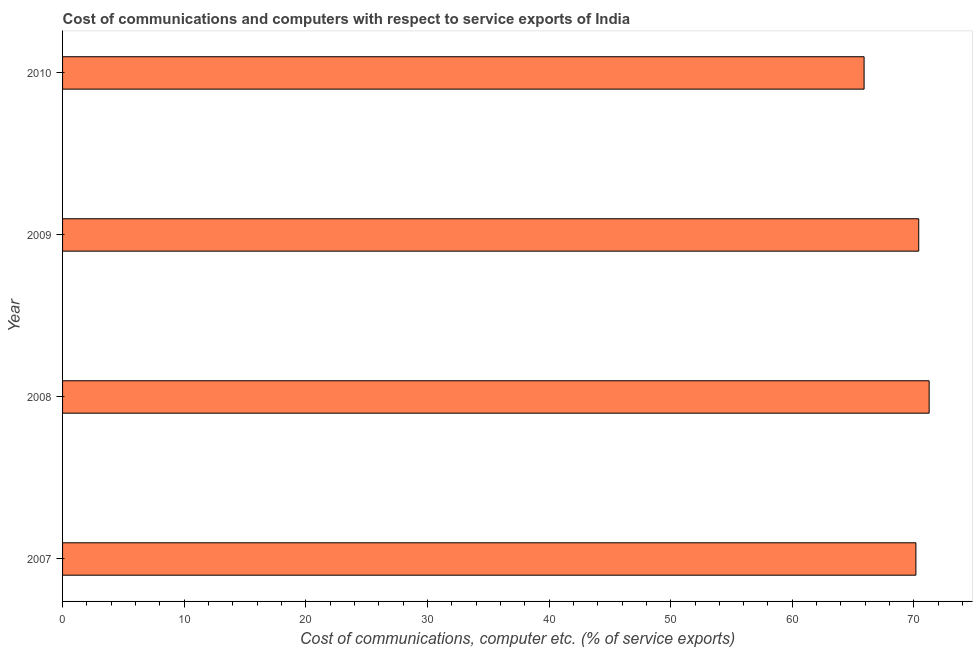Does the graph contain grids?
Your response must be concise. No. What is the title of the graph?
Keep it short and to the point. Cost of communications and computers with respect to service exports of India. What is the label or title of the X-axis?
Provide a short and direct response. Cost of communications, computer etc. (% of service exports). What is the label or title of the Y-axis?
Give a very brief answer. Year. What is the cost of communications and computer in 2008?
Offer a terse response. 71.25. Across all years, what is the maximum cost of communications and computer?
Make the answer very short. 71.25. Across all years, what is the minimum cost of communications and computer?
Make the answer very short. 65.9. What is the sum of the cost of communications and computer?
Your answer should be very brief. 277.71. What is the difference between the cost of communications and computer in 2007 and 2009?
Provide a short and direct response. -0.23. What is the average cost of communications and computer per year?
Make the answer very short. 69.43. What is the median cost of communications and computer?
Provide a succinct answer. 70.28. Do a majority of the years between 2009 and 2010 (inclusive) have cost of communications and computer greater than 26 %?
Your answer should be compact. Yes. What is the ratio of the cost of communications and computer in 2008 to that in 2009?
Give a very brief answer. 1.01. Is the difference between the cost of communications and computer in 2007 and 2009 greater than the difference between any two years?
Keep it short and to the point. No. What is the difference between the highest and the second highest cost of communications and computer?
Keep it short and to the point. 0.86. Is the sum of the cost of communications and computer in 2008 and 2010 greater than the maximum cost of communications and computer across all years?
Give a very brief answer. Yes. What is the difference between the highest and the lowest cost of communications and computer?
Make the answer very short. 5.35. Are all the bars in the graph horizontal?
Keep it short and to the point. Yes. How many years are there in the graph?
Keep it short and to the point. 4. What is the Cost of communications, computer etc. (% of service exports) of 2007?
Provide a short and direct response. 70.16. What is the Cost of communications, computer etc. (% of service exports) in 2008?
Keep it short and to the point. 71.25. What is the Cost of communications, computer etc. (% of service exports) of 2009?
Keep it short and to the point. 70.39. What is the Cost of communications, computer etc. (% of service exports) in 2010?
Your answer should be compact. 65.9. What is the difference between the Cost of communications, computer etc. (% of service exports) in 2007 and 2008?
Your response must be concise. -1.09. What is the difference between the Cost of communications, computer etc. (% of service exports) in 2007 and 2009?
Offer a terse response. -0.23. What is the difference between the Cost of communications, computer etc. (% of service exports) in 2007 and 2010?
Provide a short and direct response. 4.26. What is the difference between the Cost of communications, computer etc. (% of service exports) in 2008 and 2009?
Provide a succinct answer. 0.86. What is the difference between the Cost of communications, computer etc. (% of service exports) in 2008 and 2010?
Provide a short and direct response. 5.35. What is the difference between the Cost of communications, computer etc. (% of service exports) in 2009 and 2010?
Your answer should be very brief. 4.49. What is the ratio of the Cost of communications, computer etc. (% of service exports) in 2007 to that in 2008?
Make the answer very short. 0.98. What is the ratio of the Cost of communications, computer etc. (% of service exports) in 2007 to that in 2009?
Keep it short and to the point. 1. What is the ratio of the Cost of communications, computer etc. (% of service exports) in 2007 to that in 2010?
Provide a short and direct response. 1.06. What is the ratio of the Cost of communications, computer etc. (% of service exports) in 2008 to that in 2010?
Ensure brevity in your answer.  1.08. What is the ratio of the Cost of communications, computer etc. (% of service exports) in 2009 to that in 2010?
Your response must be concise. 1.07. 